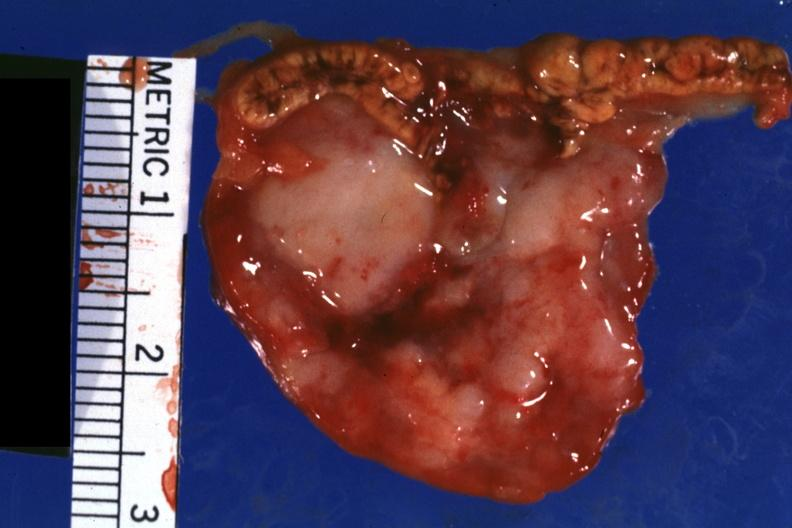what is shown well?
Answer the question using a single word or phrase. Close-up tumor 